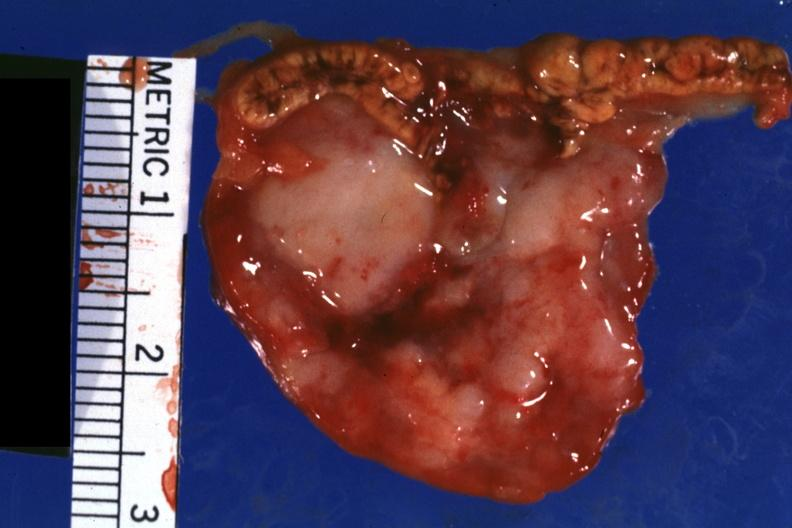what is shown well?
Answer the question using a single word or phrase. Close-up tumor 